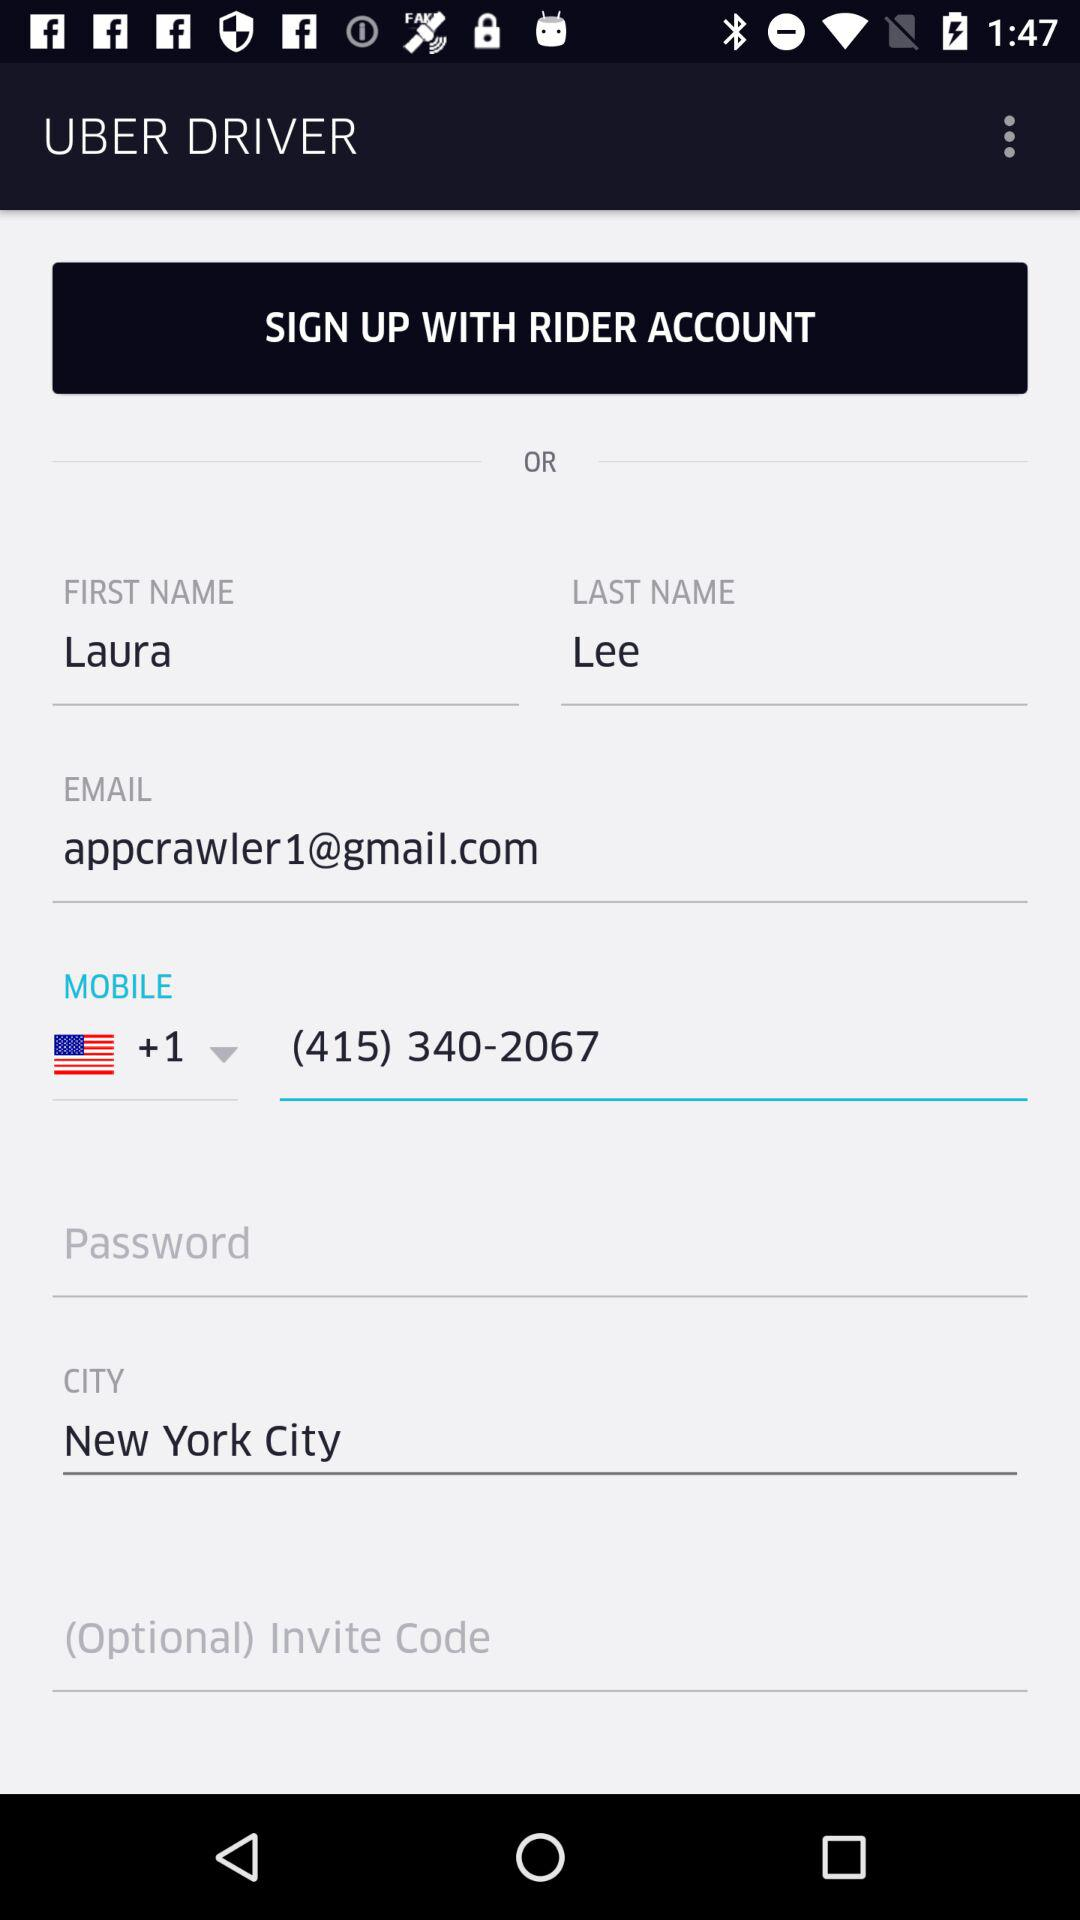What city is mentioned? The mentioned city is New York City. 